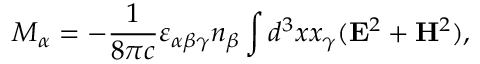<formula> <loc_0><loc_0><loc_500><loc_500>M _ { \alpha } = - { \frac { 1 } { 8 \pi c } } \varepsilon _ { \alpha \beta \gamma } n _ { \beta } \int { d ^ { 3 } x x _ { \gamma } ( { E } ^ { 2 } + { H } ^ { 2 } ) } ,</formula> 